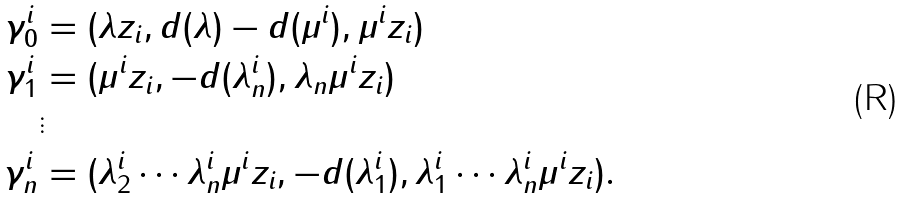<formula> <loc_0><loc_0><loc_500><loc_500>\gamma _ { 0 } ^ { i } & = ( \lambda z _ { i } , d ( \lambda ) - d ( \mu ^ { i } ) , \mu ^ { i } z _ { i } ) \\ \gamma _ { 1 } ^ { i } & = ( \mu ^ { i } z _ { i } , - d ( \lambda ^ { i } _ { n } ) , \lambda _ { n } \mu ^ { i } z _ { i } ) \\ & \vdots \\ \gamma _ { n } ^ { i } & = ( \lambda ^ { i } _ { 2 } \cdots \lambda ^ { i } _ { n } \mu ^ { i } z _ { i } , - d ( \lambda ^ { i } _ { 1 } ) , \lambda _ { 1 } ^ { i } \cdots \lambda _ { n } ^ { i } \mu ^ { i } z _ { i } ) .</formula> 